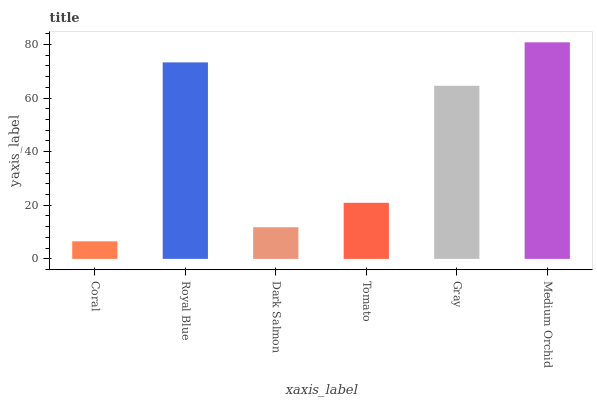Is Coral the minimum?
Answer yes or no. Yes. Is Medium Orchid the maximum?
Answer yes or no. Yes. Is Royal Blue the minimum?
Answer yes or no. No. Is Royal Blue the maximum?
Answer yes or no. No. Is Royal Blue greater than Coral?
Answer yes or no. Yes. Is Coral less than Royal Blue?
Answer yes or no. Yes. Is Coral greater than Royal Blue?
Answer yes or no. No. Is Royal Blue less than Coral?
Answer yes or no. No. Is Gray the high median?
Answer yes or no. Yes. Is Tomato the low median?
Answer yes or no. Yes. Is Dark Salmon the high median?
Answer yes or no. No. Is Gray the low median?
Answer yes or no. No. 